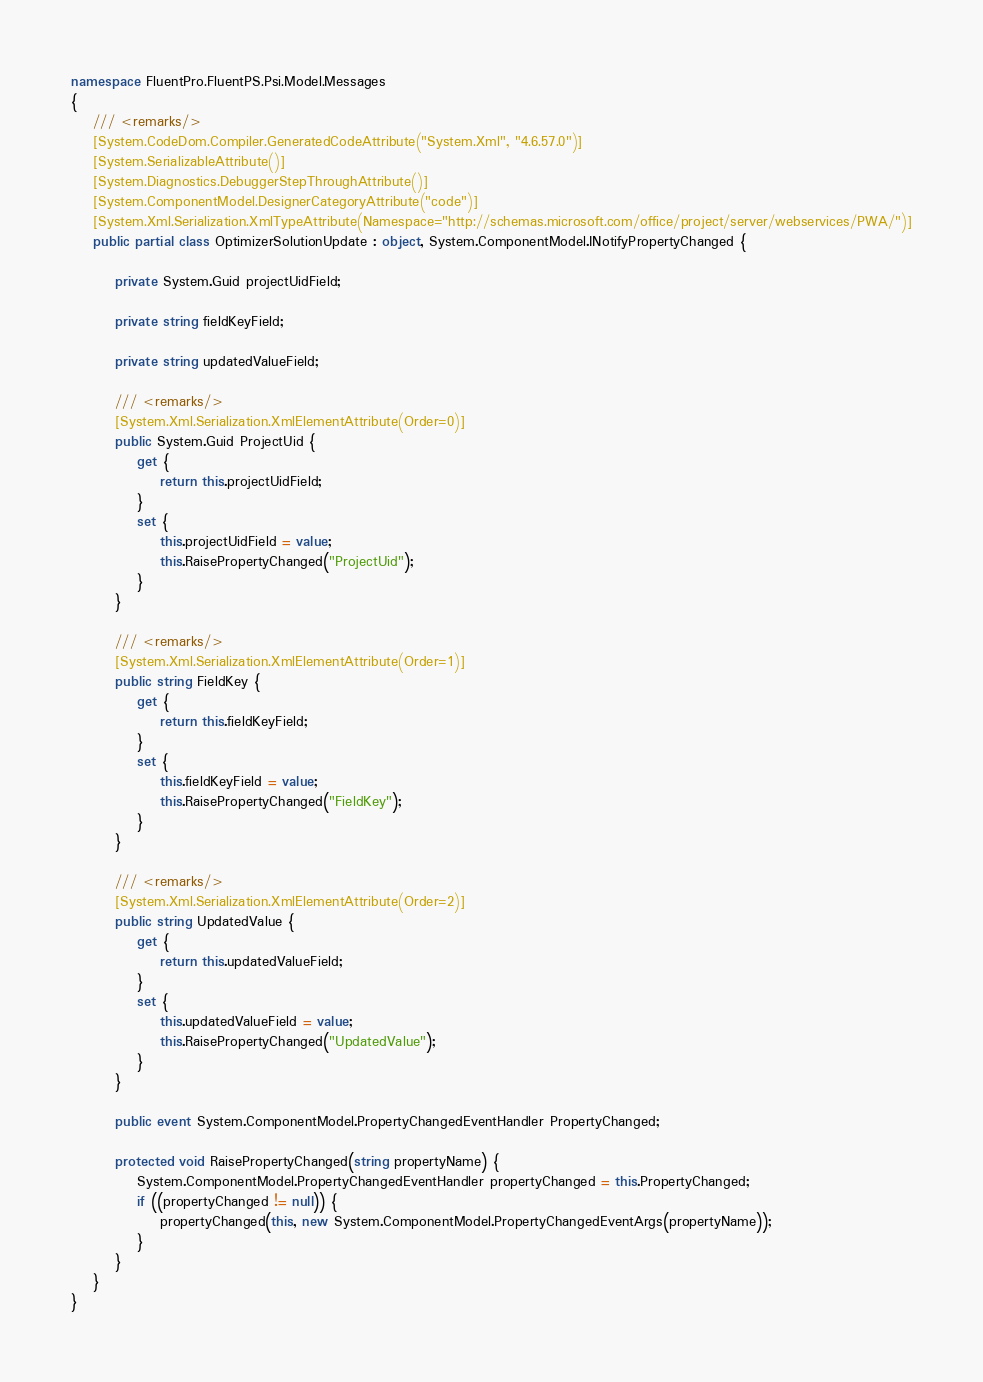Convert code to text. <code><loc_0><loc_0><loc_500><loc_500><_C#_>namespace FluentPro.FluentPS.Psi.Model.Messages
{
    /// <remarks/>
    [System.CodeDom.Compiler.GeneratedCodeAttribute("System.Xml", "4.6.57.0")]
    [System.SerializableAttribute()]
    [System.Diagnostics.DebuggerStepThroughAttribute()]
    [System.ComponentModel.DesignerCategoryAttribute("code")]
    [System.Xml.Serialization.XmlTypeAttribute(Namespace="http://schemas.microsoft.com/office/project/server/webservices/PWA/")]
    public partial class OptimizerSolutionUpdate : object, System.ComponentModel.INotifyPropertyChanged {
        
        private System.Guid projectUidField;
        
        private string fieldKeyField;
        
        private string updatedValueField;
        
        /// <remarks/>
        [System.Xml.Serialization.XmlElementAttribute(Order=0)]
        public System.Guid ProjectUid {
            get {
                return this.projectUidField;
            }
            set {
                this.projectUidField = value;
                this.RaisePropertyChanged("ProjectUid");
            }
        }
        
        /// <remarks/>
        [System.Xml.Serialization.XmlElementAttribute(Order=1)]
        public string FieldKey {
            get {
                return this.fieldKeyField;
            }
            set {
                this.fieldKeyField = value;
                this.RaisePropertyChanged("FieldKey");
            }
        }
        
        /// <remarks/>
        [System.Xml.Serialization.XmlElementAttribute(Order=2)]
        public string UpdatedValue {
            get {
                return this.updatedValueField;
            }
            set {
                this.updatedValueField = value;
                this.RaisePropertyChanged("UpdatedValue");
            }
        }
        
        public event System.ComponentModel.PropertyChangedEventHandler PropertyChanged;
        
        protected void RaisePropertyChanged(string propertyName) {
            System.ComponentModel.PropertyChangedEventHandler propertyChanged = this.PropertyChanged;
            if ((propertyChanged != null)) {
                propertyChanged(this, new System.ComponentModel.PropertyChangedEventArgs(propertyName));
            }
        }
    }
}</code> 